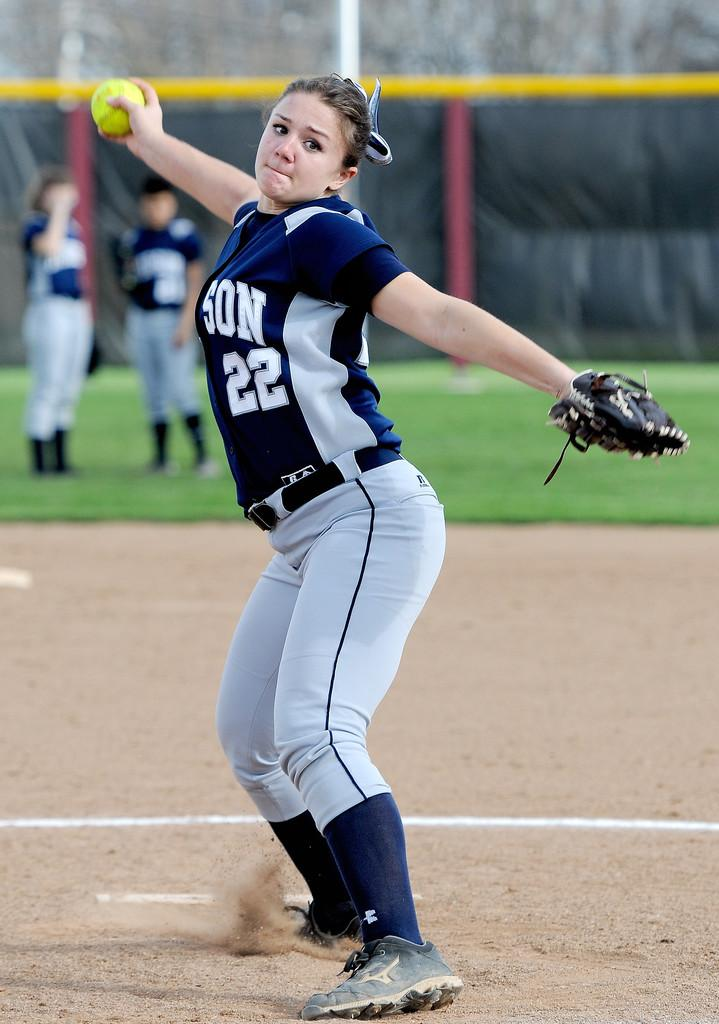<image>
Provide a brief description of the given image. A young girl in a blue and gray softball uniform with the number 22 on it about to throw a ball. 